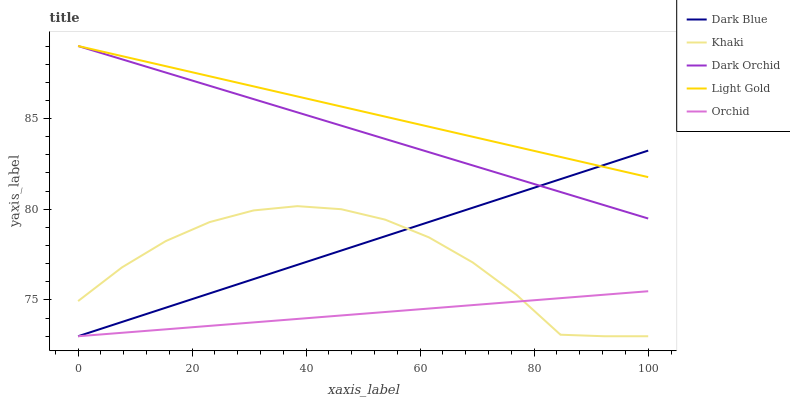Does Orchid have the minimum area under the curve?
Answer yes or no. Yes. Does Light Gold have the maximum area under the curve?
Answer yes or no. Yes. Does Khaki have the minimum area under the curve?
Answer yes or no. No. Does Khaki have the maximum area under the curve?
Answer yes or no. No. Is Orchid the smoothest?
Answer yes or no. Yes. Is Khaki the roughest?
Answer yes or no. Yes. Is Light Gold the smoothest?
Answer yes or no. No. Is Light Gold the roughest?
Answer yes or no. No. Does Dark Blue have the lowest value?
Answer yes or no. Yes. Does Light Gold have the lowest value?
Answer yes or no. No. Does Dark Orchid have the highest value?
Answer yes or no. Yes. Does Khaki have the highest value?
Answer yes or no. No. Is Khaki less than Dark Orchid?
Answer yes or no. Yes. Is Light Gold greater than Khaki?
Answer yes or no. Yes. Does Orchid intersect Khaki?
Answer yes or no. Yes. Is Orchid less than Khaki?
Answer yes or no. No. Is Orchid greater than Khaki?
Answer yes or no. No. Does Khaki intersect Dark Orchid?
Answer yes or no. No. 